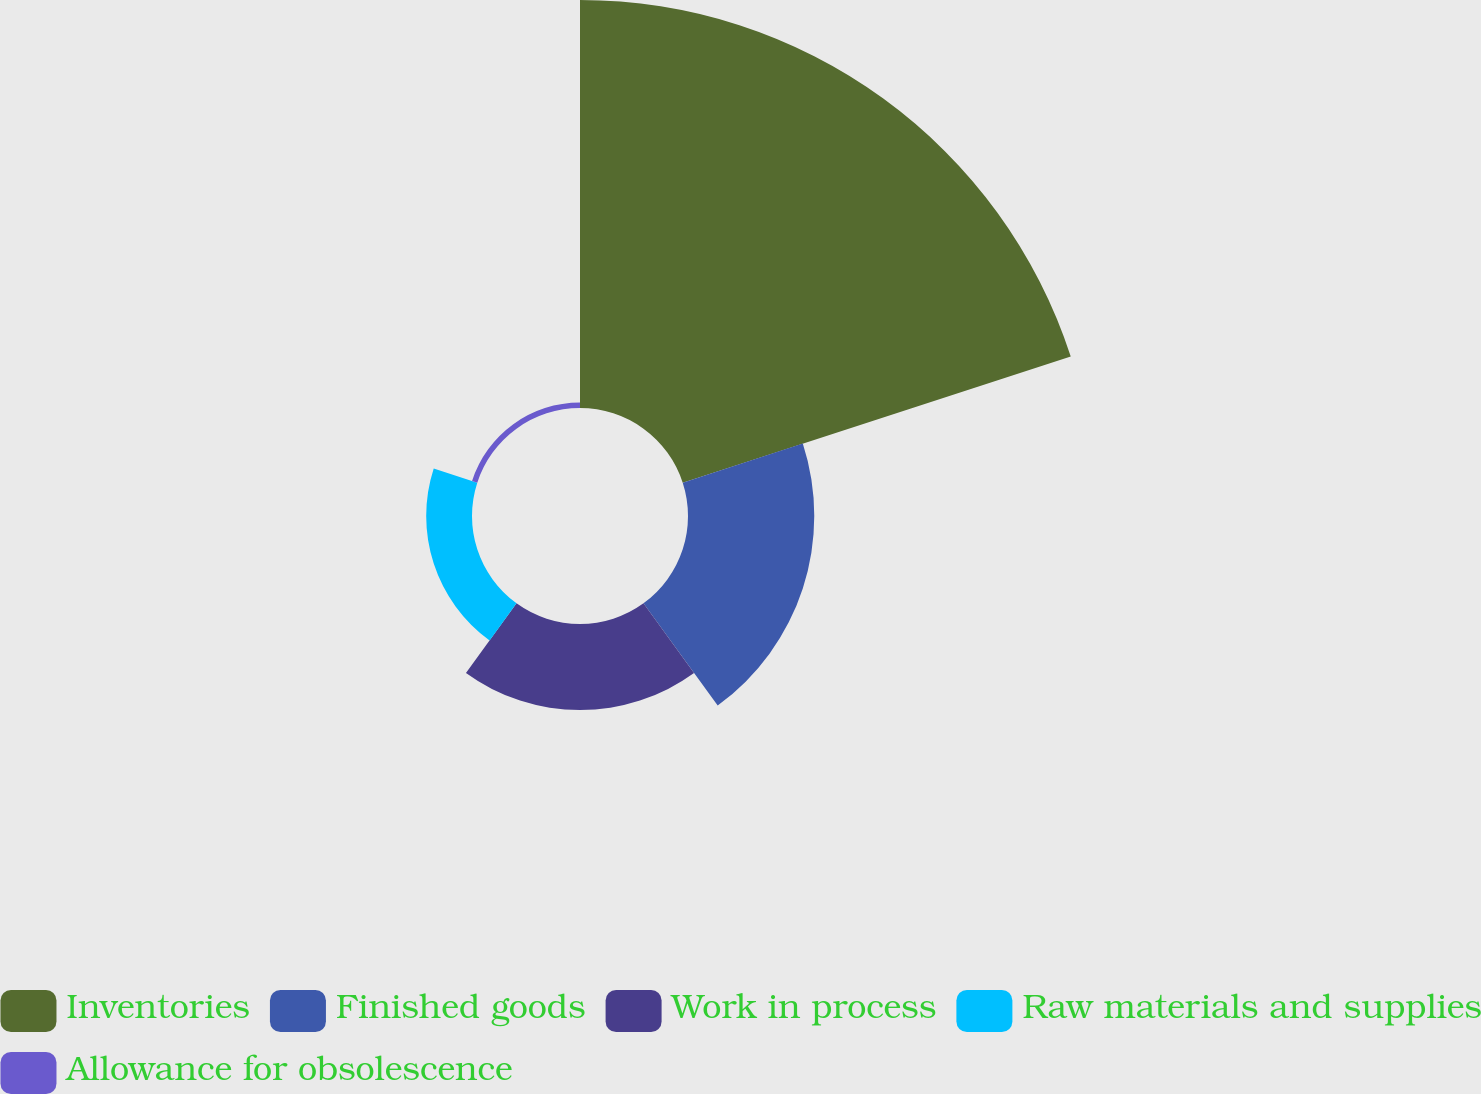Convert chart to OTSL. <chart><loc_0><loc_0><loc_500><loc_500><pie_chart><fcel>Inventories<fcel>Finished goods<fcel>Work in process<fcel>Raw materials and supplies<fcel>Allowance for obsolescence<nl><fcel>60.75%<fcel>18.8%<fcel>12.81%<fcel>6.82%<fcel>0.82%<nl></chart> 